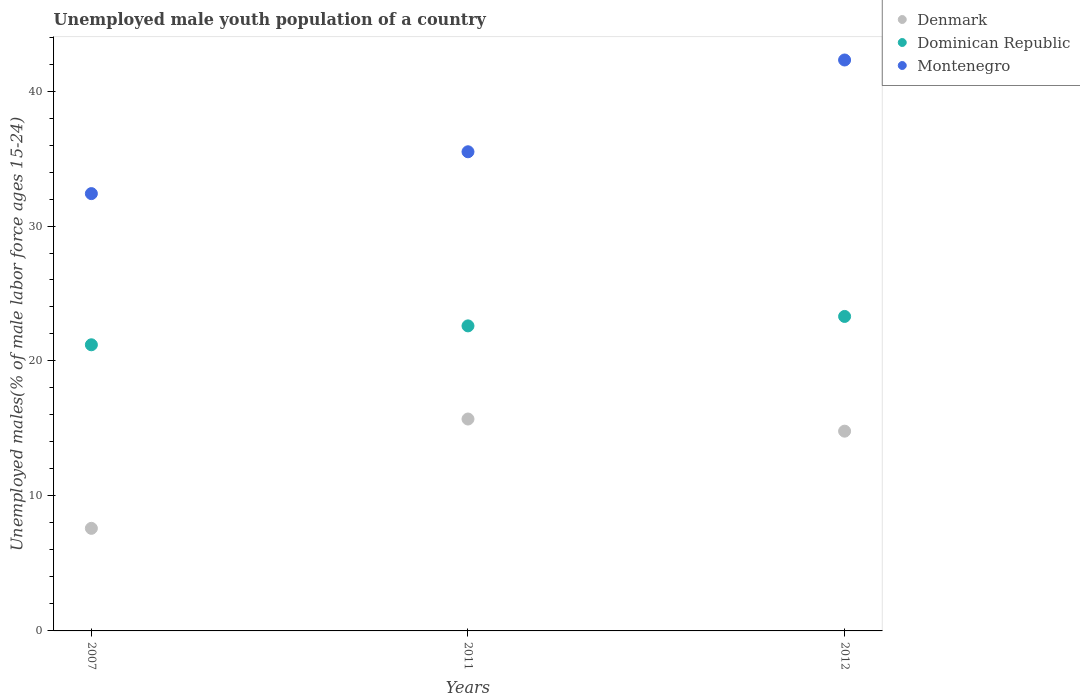Is the number of dotlines equal to the number of legend labels?
Provide a succinct answer. Yes. What is the percentage of unemployed male youth population in Dominican Republic in 2012?
Provide a short and direct response. 23.3. Across all years, what is the maximum percentage of unemployed male youth population in Dominican Republic?
Give a very brief answer. 23.3. Across all years, what is the minimum percentage of unemployed male youth population in Denmark?
Offer a terse response. 7.6. What is the total percentage of unemployed male youth population in Montenegro in the graph?
Make the answer very short. 110.2. What is the difference between the percentage of unemployed male youth population in Montenegro in 2007 and that in 2012?
Provide a succinct answer. -9.9. What is the difference between the percentage of unemployed male youth population in Montenegro in 2011 and the percentage of unemployed male youth population in Denmark in 2012?
Make the answer very short. 20.7. What is the average percentage of unemployed male youth population in Dominican Republic per year?
Your answer should be very brief. 22.37. In the year 2007, what is the difference between the percentage of unemployed male youth population in Montenegro and percentage of unemployed male youth population in Dominican Republic?
Offer a terse response. 11.2. What is the ratio of the percentage of unemployed male youth population in Denmark in 2011 to that in 2012?
Give a very brief answer. 1.06. Is the percentage of unemployed male youth population in Denmark in 2011 less than that in 2012?
Make the answer very short. No. Is the difference between the percentage of unemployed male youth population in Montenegro in 2007 and 2012 greater than the difference between the percentage of unemployed male youth population in Dominican Republic in 2007 and 2012?
Keep it short and to the point. No. What is the difference between the highest and the second highest percentage of unemployed male youth population in Denmark?
Your answer should be very brief. 0.9. What is the difference between the highest and the lowest percentage of unemployed male youth population in Denmark?
Provide a short and direct response. 8.1. In how many years, is the percentage of unemployed male youth population in Dominican Republic greater than the average percentage of unemployed male youth population in Dominican Republic taken over all years?
Offer a very short reply. 2. Is the percentage of unemployed male youth population in Denmark strictly greater than the percentage of unemployed male youth population in Montenegro over the years?
Ensure brevity in your answer.  No. Is the percentage of unemployed male youth population in Dominican Republic strictly less than the percentage of unemployed male youth population in Denmark over the years?
Provide a succinct answer. No. How many dotlines are there?
Offer a terse response. 3. How many years are there in the graph?
Offer a terse response. 3. What is the difference between two consecutive major ticks on the Y-axis?
Your answer should be compact. 10. Does the graph contain any zero values?
Provide a short and direct response. No. Where does the legend appear in the graph?
Offer a very short reply. Top right. How many legend labels are there?
Provide a short and direct response. 3. How are the legend labels stacked?
Provide a succinct answer. Vertical. What is the title of the graph?
Your answer should be very brief. Unemployed male youth population of a country. Does "Zimbabwe" appear as one of the legend labels in the graph?
Offer a very short reply. No. What is the label or title of the Y-axis?
Your answer should be compact. Unemployed males(% of male labor force ages 15-24). What is the Unemployed males(% of male labor force ages 15-24) in Denmark in 2007?
Keep it short and to the point. 7.6. What is the Unemployed males(% of male labor force ages 15-24) of Dominican Republic in 2007?
Provide a succinct answer. 21.2. What is the Unemployed males(% of male labor force ages 15-24) in Montenegro in 2007?
Ensure brevity in your answer.  32.4. What is the Unemployed males(% of male labor force ages 15-24) of Denmark in 2011?
Offer a very short reply. 15.7. What is the Unemployed males(% of male labor force ages 15-24) of Dominican Republic in 2011?
Offer a very short reply. 22.6. What is the Unemployed males(% of male labor force ages 15-24) of Montenegro in 2011?
Your response must be concise. 35.5. What is the Unemployed males(% of male labor force ages 15-24) in Denmark in 2012?
Your answer should be compact. 14.8. What is the Unemployed males(% of male labor force ages 15-24) of Dominican Republic in 2012?
Your answer should be compact. 23.3. What is the Unemployed males(% of male labor force ages 15-24) of Montenegro in 2012?
Your answer should be very brief. 42.3. Across all years, what is the maximum Unemployed males(% of male labor force ages 15-24) in Denmark?
Offer a terse response. 15.7. Across all years, what is the maximum Unemployed males(% of male labor force ages 15-24) of Dominican Republic?
Offer a terse response. 23.3. Across all years, what is the maximum Unemployed males(% of male labor force ages 15-24) of Montenegro?
Ensure brevity in your answer.  42.3. Across all years, what is the minimum Unemployed males(% of male labor force ages 15-24) in Denmark?
Keep it short and to the point. 7.6. Across all years, what is the minimum Unemployed males(% of male labor force ages 15-24) in Dominican Republic?
Offer a very short reply. 21.2. Across all years, what is the minimum Unemployed males(% of male labor force ages 15-24) in Montenegro?
Make the answer very short. 32.4. What is the total Unemployed males(% of male labor force ages 15-24) in Denmark in the graph?
Your response must be concise. 38.1. What is the total Unemployed males(% of male labor force ages 15-24) of Dominican Republic in the graph?
Offer a very short reply. 67.1. What is the total Unemployed males(% of male labor force ages 15-24) of Montenegro in the graph?
Offer a very short reply. 110.2. What is the difference between the Unemployed males(% of male labor force ages 15-24) in Denmark in 2007 and that in 2011?
Your response must be concise. -8.1. What is the difference between the Unemployed males(% of male labor force ages 15-24) of Dominican Republic in 2007 and that in 2011?
Your answer should be very brief. -1.4. What is the difference between the Unemployed males(% of male labor force ages 15-24) in Montenegro in 2007 and that in 2011?
Your answer should be compact. -3.1. What is the difference between the Unemployed males(% of male labor force ages 15-24) of Montenegro in 2007 and that in 2012?
Your answer should be compact. -9.9. What is the difference between the Unemployed males(% of male labor force ages 15-24) in Denmark in 2011 and that in 2012?
Ensure brevity in your answer.  0.9. What is the difference between the Unemployed males(% of male labor force ages 15-24) of Dominican Republic in 2011 and that in 2012?
Your answer should be very brief. -0.7. What is the difference between the Unemployed males(% of male labor force ages 15-24) of Montenegro in 2011 and that in 2012?
Your response must be concise. -6.8. What is the difference between the Unemployed males(% of male labor force ages 15-24) of Denmark in 2007 and the Unemployed males(% of male labor force ages 15-24) of Dominican Republic in 2011?
Provide a short and direct response. -15. What is the difference between the Unemployed males(% of male labor force ages 15-24) in Denmark in 2007 and the Unemployed males(% of male labor force ages 15-24) in Montenegro in 2011?
Give a very brief answer. -27.9. What is the difference between the Unemployed males(% of male labor force ages 15-24) of Dominican Republic in 2007 and the Unemployed males(% of male labor force ages 15-24) of Montenegro in 2011?
Provide a succinct answer. -14.3. What is the difference between the Unemployed males(% of male labor force ages 15-24) in Denmark in 2007 and the Unemployed males(% of male labor force ages 15-24) in Dominican Republic in 2012?
Your answer should be very brief. -15.7. What is the difference between the Unemployed males(% of male labor force ages 15-24) of Denmark in 2007 and the Unemployed males(% of male labor force ages 15-24) of Montenegro in 2012?
Your answer should be compact. -34.7. What is the difference between the Unemployed males(% of male labor force ages 15-24) in Dominican Republic in 2007 and the Unemployed males(% of male labor force ages 15-24) in Montenegro in 2012?
Ensure brevity in your answer.  -21.1. What is the difference between the Unemployed males(% of male labor force ages 15-24) of Denmark in 2011 and the Unemployed males(% of male labor force ages 15-24) of Montenegro in 2012?
Give a very brief answer. -26.6. What is the difference between the Unemployed males(% of male labor force ages 15-24) of Dominican Republic in 2011 and the Unemployed males(% of male labor force ages 15-24) of Montenegro in 2012?
Provide a short and direct response. -19.7. What is the average Unemployed males(% of male labor force ages 15-24) of Dominican Republic per year?
Make the answer very short. 22.37. What is the average Unemployed males(% of male labor force ages 15-24) in Montenegro per year?
Provide a short and direct response. 36.73. In the year 2007, what is the difference between the Unemployed males(% of male labor force ages 15-24) in Denmark and Unemployed males(% of male labor force ages 15-24) in Dominican Republic?
Your answer should be compact. -13.6. In the year 2007, what is the difference between the Unemployed males(% of male labor force ages 15-24) of Denmark and Unemployed males(% of male labor force ages 15-24) of Montenegro?
Offer a terse response. -24.8. In the year 2007, what is the difference between the Unemployed males(% of male labor force ages 15-24) in Dominican Republic and Unemployed males(% of male labor force ages 15-24) in Montenegro?
Make the answer very short. -11.2. In the year 2011, what is the difference between the Unemployed males(% of male labor force ages 15-24) of Denmark and Unemployed males(% of male labor force ages 15-24) of Montenegro?
Give a very brief answer. -19.8. In the year 2012, what is the difference between the Unemployed males(% of male labor force ages 15-24) of Denmark and Unemployed males(% of male labor force ages 15-24) of Montenegro?
Provide a short and direct response. -27.5. In the year 2012, what is the difference between the Unemployed males(% of male labor force ages 15-24) in Dominican Republic and Unemployed males(% of male labor force ages 15-24) in Montenegro?
Your answer should be compact. -19. What is the ratio of the Unemployed males(% of male labor force ages 15-24) of Denmark in 2007 to that in 2011?
Provide a succinct answer. 0.48. What is the ratio of the Unemployed males(% of male labor force ages 15-24) of Dominican Republic in 2007 to that in 2011?
Ensure brevity in your answer.  0.94. What is the ratio of the Unemployed males(% of male labor force ages 15-24) of Montenegro in 2007 to that in 2011?
Ensure brevity in your answer.  0.91. What is the ratio of the Unemployed males(% of male labor force ages 15-24) of Denmark in 2007 to that in 2012?
Your answer should be compact. 0.51. What is the ratio of the Unemployed males(% of male labor force ages 15-24) in Dominican Republic in 2007 to that in 2012?
Make the answer very short. 0.91. What is the ratio of the Unemployed males(% of male labor force ages 15-24) of Montenegro in 2007 to that in 2012?
Give a very brief answer. 0.77. What is the ratio of the Unemployed males(% of male labor force ages 15-24) in Denmark in 2011 to that in 2012?
Keep it short and to the point. 1.06. What is the ratio of the Unemployed males(% of male labor force ages 15-24) of Dominican Republic in 2011 to that in 2012?
Offer a very short reply. 0.97. What is the ratio of the Unemployed males(% of male labor force ages 15-24) of Montenegro in 2011 to that in 2012?
Your response must be concise. 0.84. What is the difference between the highest and the second highest Unemployed males(% of male labor force ages 15-24) in Denmark?
Ensure brevity in your answer.  0.9. What is the difference between the highest and the second highest Unemployed males(% of male labor force ages 15-24) in Montenegro?
Provide a succinct answer. 6.8. What is the difference between the highest and the lowest Unemployed males(% of male labor force ages 15-24) of Denmark?
Offer a very short reply. 8.1. What is the difference between the highest and the lowest Unemployed males(% of male labor force ages 15-24) in Montenegro?
Offer a terse response. 9.9. 